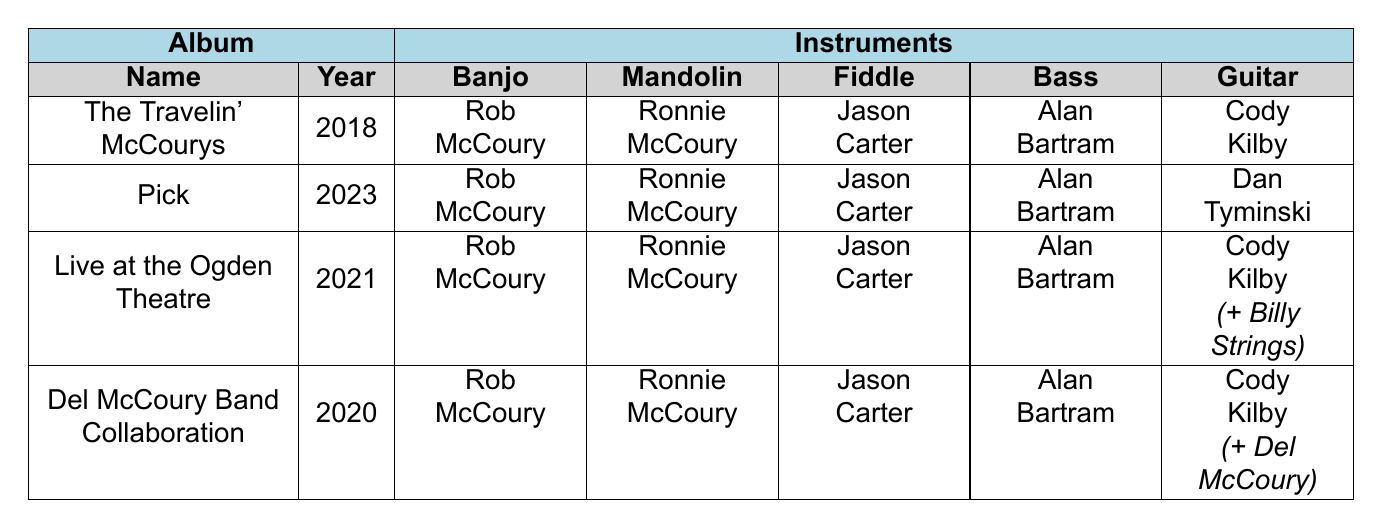What instruments does Ronnie McCoury play in the albums listed? In the table, under each album's members, Ronnie McCoury's instrument is consistently listed as "Mandolin."
Answer: Mandolin In how many albums does Cody Kilby play guitar? By reviewing the members listed under each album, Cody Kilby is mentioned as playing guitar in three albums: “The Travelin' McCourys,” “Live at the Ogden Theatre,” and “Del McCoury Band Collaboration.”
Answer: 3 Which member plays the banjo in each album? Each album listed includes Rob McCoury as the banjo player. This can be confirmed by checking the 'Banjo' column for all albums listed.
Answer: Rob McCoury Is there an album featuring a guest musician? Yes, both “Live at the Ogden Theatre” and “Del McCoury Band Collaboration” feature guest musicians (Billy Strings and Del McCoury, respectively). This is indicated by the notation under the member listings for those albums.
Answer: Yes Which instruments are played by the band members in the album "Pick"? Referring to the “Pick” album, the instruments played by the members are: Banjo (Rob McCoury), Mandolin (Ronnie McCoury), Fiddle (Jason Carter), Bass (Alan Bartram), and Guitar (Dan Tyminski).
Answer: Banjo, Mandolin, Fiddle, Bass, Guitar What is the year of the album that has the most members listed? The "Live at the Ogden Theatre" has a total of six members, the most of any album listed, which includes a guest musician. Other albums have five members. The year of this album is 2021.
Answer: 2021 How does the guitar player change from "The Travelin' McCourys" to "Pick"? In "The Travelin' McCourys," Cody Kilby is the guitar player, while in "Pick," Dan Tyminski replaces him as the guitar player.
Answer: Dan Tyminski replaces Cody Kilby What is the relationship between the albums "Del McCoury Band Collaboration" and the musicians listed? The album "Del McCoury Band Collaboration" features the same core members as other albums, with the addition of Del McCoury as a guest musician playing guitar and vocals. This demonstrates the collaboration aspect.
Answer: Same core members plus Del McCoury as guest Which instrument is not played by Alan Bartram in any of the albums? Alan Bartram consistently plays the Bass in all listed albums, so he does not play any other instrument. The table confirms his role across all albums.
Answer: None, he plays Bass only What is the total number of unique instruments played among the members listed for all albums? The unique instruments listed among all albums are Banjo, Mandolin, Fiddle, Bass, Guitar, and Guest Guitar. Counting these gives a total of six unique instruments.
Answer: 6 